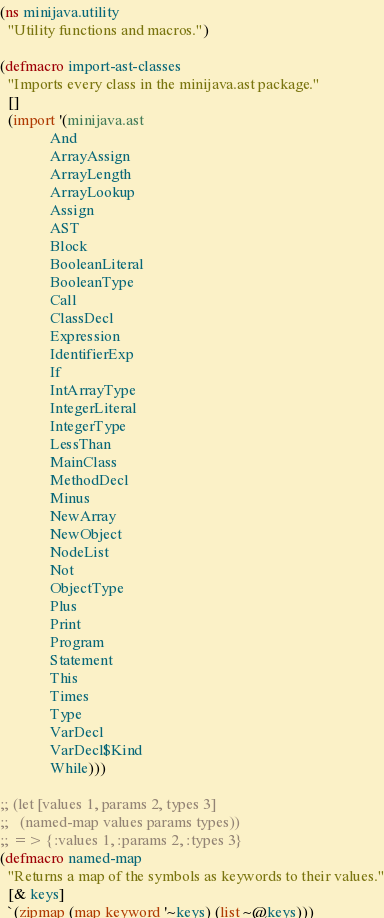Convert code to text. <code><loc_0><loc_0><loc_500><loc_500><_Clojure_>(ns minijava.utility
  "Utility functions and macros.")

(defmacro import-ast-classes
  "Imports every class in the minijava.ast package."
  []
  (import '(minijava.ast
             And
             ArrayAssign
             ArrayLength
             ArrayLookup
             Assign
             AST
             Block
             BooleanLiteral
             BooleanType
             Call
             ClassDecl
             Expression
             IdentifierExp
             If
             IntArrayType
             IntegerLiteral
             IntegerType
             LessThan
             MainClass
             MethodDecl
             Minus
             NewArray
             NewObject
             NodeList
             Not
             ObjectType
             Plus
             Print
             Program
             Statement
             This
             Times
             Type
             VarDecl
             VarDecl$Kind
             While)))

;; (let [values 1, params 2, types 3]
;;   (named-map values params types))
;; => {:values 1, :params 2, :types 3}
(defmacro named-map
  "Returns a map of the symbols as keywords to their values."
  [& keys]
  `(zipmap (map keyword '~keys) (list ~@keys)))</code> 